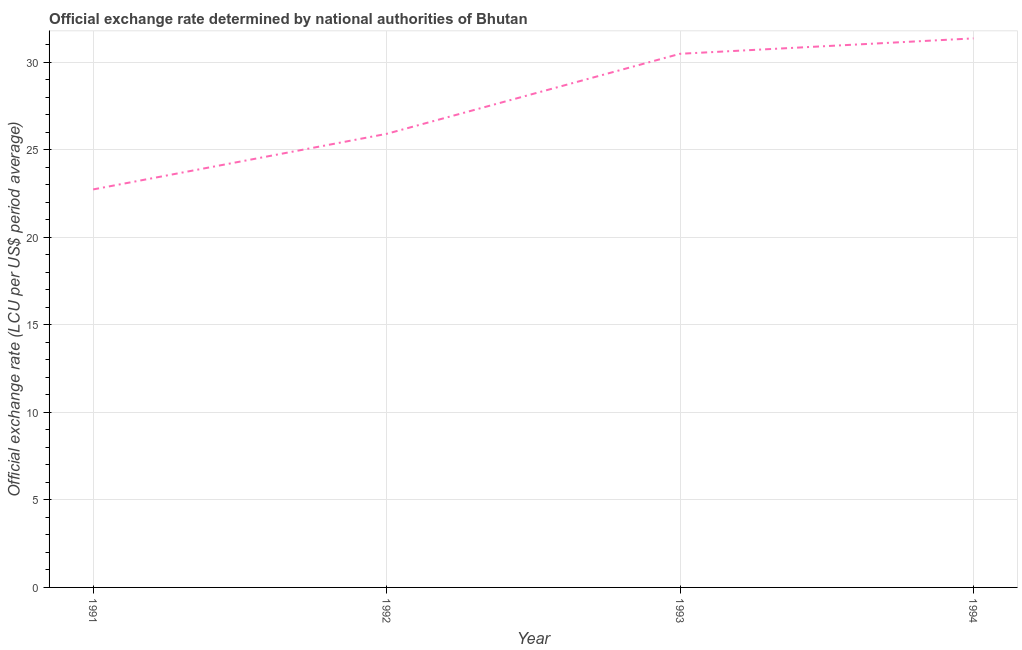What is the official exchange rate in 1993?
Give a very brief answer. 30.49. Across all years, what is the maximum official exchange rate?
Your answer should be very brief. 31.37. Across all years, what is the minimum official exchange rate?
Make the answer very short. 22.74. What is the sum of the official exchange rate?
Give a very brief answer. 110.53. What is the difference between the official exchange rate in 1991 and 1992?
Ensure brevity in your answer.  -3.18. What is the average official exchange rate per year?
Make the answer very short. 27.63. What is the median official exchange rate?
Make the answer very short. 28.21. Do a majority of the years between 1993 and 1992 (inclusive) have official exchange rate greater than 6 ?
Provide a succinct answer. No. What is the ratio of the official exchange rate in 1991 to that in 1993?
Your answer should be compact. 0.75. Is the difference between the official exchange rate in 1993 and 1994 greater than the difference between any two years?
Your response must be concise. No. What is the difference between the highest and the second highest official exchange rate?
Your answer should be compact. 0.88. Is the sum of the official exchange rate in 1993 and 1994 greater than the maximum official exchange rate across all years?
Offer a very short reply. Yes. What is the difference between the highest and the lowest official exchange rate?
Your answer should be compact. 8.63. In how many years, is the official exchange rate greater than the average official exchange rate taken over all years?
Your answer should be very brief. 2. Does the official exchange rate monotonically increase over the years?
Keep it short and to the point. Yes. How many lines are there?
Offer a very short reply. 1. How many years are there in the graph?
Your answer should be compact. 4. Does the graph contain any zero values?
Give a very brief answer. No. Does the graph contain grids?
Make the answer very short. Yes. What is the title of the graph?
Provide a succinct answer. Official exchange rate determined by national authorities of Bhutan. What is the label or title of the X-axis?
Make the answer very short. Year. What is the label or title of the Y-axis?
Ensure brevity in your answer.  Official exchange rate (LCU per US$ period average). What is the Official exchange rate (LCU per US$ period average) of 1991?
Your answer should be compact. 22.74. What is the Official exchange rate (LCU per US$ period average) in 1992?
Provide a succinct answer. 25.92. What is the Official exchange rate (LCU per US$ period average) in 1993?
Your response must be concise. 30.49. What is the Official exchange rate (LCU per US$ period average) in 1994?
Provide a succinct answer. 31.37. What is the difference between the Official exchange rate (LCU per US$ period average) in 1991 and 1992?
Offer a terse response. -3.18. What is the difference between the Official exchange rate (LCU per US$ period average) in 1991 and 1993?
Offer a terse response. -7.75. What is the difference between the Official exchange rate (LCU per US$ period average) in 1991 and 1994?
Provide a succinct answer. -8.63. What is the difference between the Official exchange rate (LCU per US$ period average) in 1992 and 1993?
Offer a very short reply. -4.58. What is the difference between the Official exchange rate (LCU per US$ period average) in 1992 and 1994?
Ensure brevity in your answer.  -5.46. What is the difference between the Official exchange rate (LCU per US$ period average) in 1993 and 1994?
Your answer should be compact. -0.88. What is the ratio of the Official exchange rate (LCU per US$ period average) in 1991 to that in 1992?
Your response must be concise. 0.88. What is the ratio of the Official exchange rate (LCU per US$ period average) in 1991 to that in 1993?
Your answer should be compact. 0.75. What is the ratio of the Official exchange rate (LCU per US$ period average) in 1991 to that in 1994?
Your answer should be compact. 0.72. What is the ratio of the Official exchange rate (LCU per US$ period average) in 1992 to that in 1994?
Ensure brevity in your answer.  0.83. 